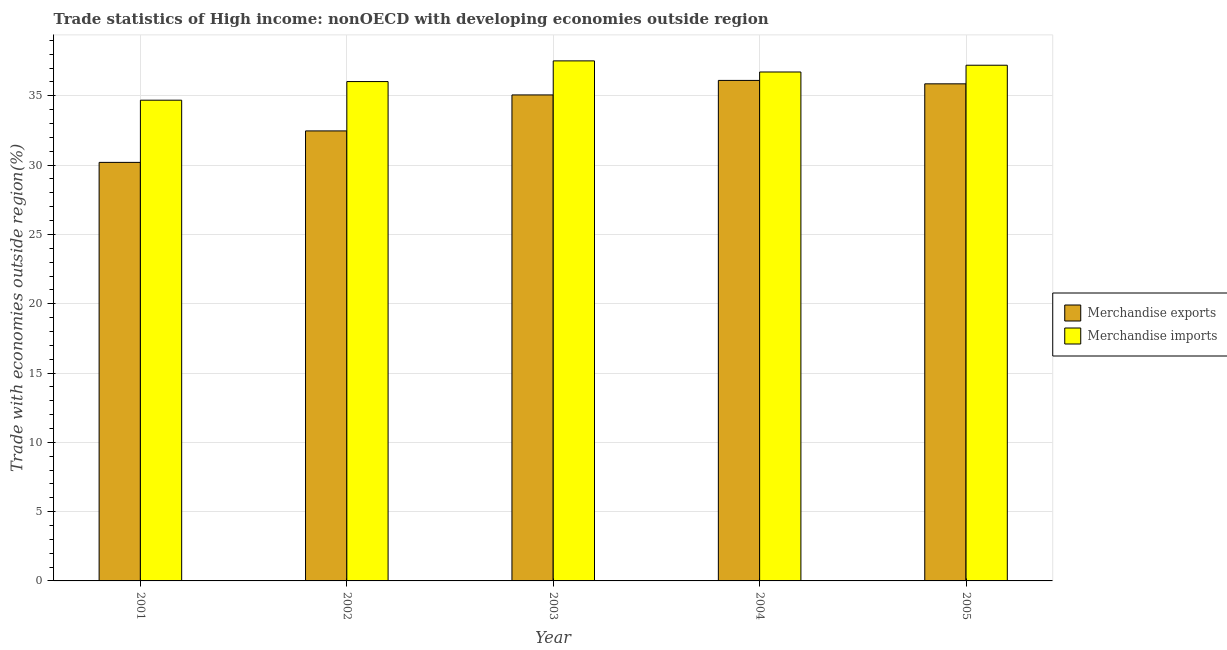How many different coloured bars are there?
Provide a succinct answer. 2. How many groups of bars are there?
Provide a succinct answer. 5. How many bars are there on the 3rd tick from the left?
Your answer should be very brief. 2. How many bars are there on the 1st tick from the right?
Make the answer very short. 2. What is the label of the 2nd group of bars from the left?
Make the answer very short. 2002. What is the merchandise exports in 2003?
Your answer should be compact. 35.07. Across all years, what is the maximum merchandise exports?
Ensure brevity in your answer.  36.11. Across all years, what is the minimum merchandise exports?
Offer a very short reply. 30.2. In which year was the merchandise exports maximum?
Keep it short and to the point. 2004. What is the total merchandise imports in the graph?
Make the answer very short. 182.17. What is the difference between the merchandise imports in 2002 and that in 2003?
Your answer should be compact. -1.49. What is the difference between the merchandise imports in 2001 and the merchandise exports in 2002?
Ensure brevity in your answer.  -1.34. What is the average merchandise imports per year?
Provide a succinct answer. 36.43. In the year 2002, what is the difference between the merchandise imports and merchandise exports?
Give a very brief answer. 0. In how many years, is the merchandise exports greater than 30 %?
Ensure brevity in your answer.  5. What is the ratio of the merchandise imports in 2001 to that in 2004?
Keep it short and to the point. 0.94. Is the difference between the merchandise exports in 2004 and 2005 greater than the difference between the merchandise imports in 2004 and 2005?
Give a very brief answer. No. What is the difference between the highest and the second highest merchandise exports?
Make the answer very short. 0.25. What is the difference between the highest and the lowest merchandise imports?
Provide a short and direct response. 2.84. In how many years, is the merchandise exports greater than the average merchandise exports taken over all years?
Your response must be concise. 3. What does the 1st bar from the left in 2005 represents?
Your answer should be compact. Merchandise exports. How many years are there in the graph?
Give a very brief answer. 5. What is the difference between two consecutive major ticks on the Y-axis?
Make the answer very short. 5. Are the values on the major ticks of Y-axis written in scientific E-notation?
Offer a very short reply. No. Does the graph contain grids?
Offer a terse response. Yes. What is the title of the graph?
Provide a succinct answer. Trade statistics of High income: nonOECD with developing economies outside region. Does "Domestic liabilities" appear as one of the legend labels in the graph?
Provide a succinct answer. No. What is the label or title of the X-axis?
Ensure brevity in your answer.  Year. What is the label or title of the Y-axis?
Your response must be concise. Trade with economies outside region(%). What is the Trade with economies outside region(%) in Merchandise exports in 2001?
Your answer should be very brief. 30.2. What is the Trade with economies outside region(%) of Merchandise imports in 2001?
Provide a succinct answer. 34.69. What is the Trade with economies outside region(%) in Merchandise exports in 2002?
Ensure brevity in your answer.  32.47. What is the Trade with economies outside region(%) in Merchandise imports in 2002?
Your answer should be compact. 36.03. What is the Trade with economies outside region(%) in Merchandise exports in 2003?
Ensure brevity in your answer.  35.07. What is the Trade with economies outside region(%) of Merchandise imports in 2003?
Give a very brief answer. 37.52. What is the Trade with economies outside region(%) in Merchandise exports in 2004?
Offer a very short reply. 36.11. What is the Trade with economies outside region(%) of Merchandise imports in 2004?
Give a very brief answer. 36.72. What is the Trade with economies outside region(%) in Merchandise exports in 2005?
Offer a very short reply. 35.87. What is the Trade with economies outside region(%) of Merchandise imports in 2005?
Ensure brevity in your answer.  37.21. Across all years, what is the maximum Trade with economies outside region(%) of Merchandise exports?
Make the answer very short. 36.11. Across all years, what is the maximum Trade with economies outside region(%) in Merchandise imports?
Give a very brief answer. 37.52. Across all years, what is the minimum Trade with economies outside region(%) in Merchandise exports?
Your answer should be very brief. 30.2. Across all years, what is the minimum Trade with economies outside region(%) in Merchandise imports?
Your response must be concise. 34.69. What is the total Trade with economies outside region(%) in Merchandise exports in the graph?
Offer a very short reply. 169.71. What is the total Trade with economies outside region(%) in Merchandise imports in the graph?
Offer a very short reply. 182.16. What is the difference between the Trade with economies outside region(%) in Merchandise exports in 2001 and that in 2002?
Your answer should be very brief. -2.27. What is the difference between the Trade with economies outside region(%) of Merchandise imports in 2001 and that in 2002?
Your answer should be compact. -1.34. What is the difference between the Trade with economies outside region(%) of Merchandise exports in 2001 and that in 2003?
Provide a succinct answer. -4.87. What is the difference between the Trade with economies outside region(%) in Merchandise imports in 2001 and that in 2003?
Your answer should be compact. -2.84. What is the difference between the Trade with economies outside region(%) in Merchandise exports in 2001 and that in 2004?
Ensure brevity in your answer.  -5.91. What is the difference between the Trade with economies outside region(%) in Merchandise imports in 2001 and that in 2004?
Provide a succinct answer. -2.03. What is the difference between the Trade with economies outside region(%) in Merchandise exports in 2001 and that in 2005?
Your answer should be very brief. -5.67. What is the difference between the Trade with economies outside region(%) of Merchandise imports in 2001 and that in 2005?
Provide a short and direct response. -2.52. What is the difference between the Trade with economies outside region(%) in Merchandise exports in 2002 and that in 2003?
Offer a very short reply. -2.6. What is the difference between the Trade with economies outside region(%) of Merchandise imports in 2002 and that in 2003?
Give a very brief answer. -1.49. What is the difference between the Trade with economies outside region(%) of Merchandise exports in 2002 and that in 2004?
Offer a terse response. -3.64. What is the difference between the Trade with economies outside region(%) of Merchandise imports in 2002 and that in 2004?
Ensure brevity in your answer.  -0.69. What is the difference between the Trade with economies outside region(%) in Merchandise exports in 2002 and that in 2005?
Offer a very short reply. -3.4. What is the difference between the Trade with economies outside region(%) of Merchandise imports in 2002 and that in 2005?
Keep it short and to the point. -1.18. What is the difference between the Trade with economies outside region(%) of Merchandise exports in 2003 and that in 2004?
Make the answer very short. -1.05. What is the difference between the Trade with economies outside region(%) of Merchandise imports in 2003 and that in 2004?
Your response must be concise. 0.8. What is the difference between the Trade with economies outside region(%) in Merchandise exports in 2003 and that in 2005?
Your answer should be compact. -0.8. What is the difference between the Trade with economies outside region(%) in Merchandise imports in 2003 and that in 2005?
Your answer should be compact. 0.31. What is the difference between the Trade with economies outside region(%) in Merchandise exports in 2004 and that in 2005?
Provide a short and direct response. 0.25. What is the difference between the Trade with economies outside region(%) in Merchandise imports in 2004 and that in 2005?
Give a very brief answer. -0.49. What is the difference between the Trade with economies outside region(%) of Merchandise exports in 2001 and the Trade with economies outside region(%) of Merchandise imports in 2002?
Make the answer very short. -5.83. What is the difference between the Trade with economies outside region(%) of Merchandise exports in 2001 and the Trade with economies outside region(%) of Merchandise imports in 2003?
Provide a succinct answer. -7.32. What is the difference between the Trade with economies outside region(%) in Merchandise exports in 2001 and the Trade with economies outside region(%) in Merchandise imports in 2004?
Provide a short and direct response. -6.52. What is the difference between the Trade with economies outside region(%) in Merchandise exports in 2001 and the Trade with economies outside region(%) in Merchandise imports in 2005?
Make the answer very short. -7.01. What is the difference between the Trade with economies outside region(%) in Merchandise exports in 2002 and the Trade with economies outside region(%) in Merchandise imports in 2003?
Your answer should be very brief. -5.05. What is the difference between the Trade with economies outside region(%) in Merchandise exports in 2002 and the Trade with economies outside region(%) in Merchandise imports in 2004?
Offer a terse response. -4.25. What is the difference between the Trade with economies outside region(%) in Merchandise exports in 2002 and the Trade with economies outside region(%) in Merchandise imports in 2005?
Make the answer very short. -4.74. What is the difference between the Trade with economies outside region(%) in Merchandise exports in 2003 and the Trade with economies outside region(%) in Merchandise imports in 2004?
Your answer should be very brief. -1.65. What is the difference between the Trade with economies outside region(%) of Merchandise exports in 2003 and the Trade with economies outside region(%) of Merchandise imports in 2005?
Provide a short and direct response. -2.14. What is the difference between the Trade with economies outside region(%) of Merchandise exports in 2004 and the Trade with economies outside region(%) of Merchandise imports in 2005?
Provide a succinct answer. -1.1. What is the average Trade with economies outside region(%) of Merchandise exports per year?
Keep it short and to the point. 33.94. What is the average Trade with economies outside region(%) in Merchandise imports per year?
Keep it short and to the point. 36.43. In the year 2001, what is the difference between the Trade with economies outside region(%) of Merchandise exports and Trade with economies outside region(%) of Merchandise imports?
Give a very brief answer. -4.49. In the year 2002, what is the difference between the Trade with economies outside region(%) of Merchandise exports and Trade with economies outside region(%) of Merchandise imports?
Offer a terse response. -3.56. In the year 2003, what is the difference between the Trade with economies outside region(%) of Merchandise exports and Trade with economies outside region(%) of Merchandise imports?
Keep it short and to the point. -2.46. In the year 2004, what is the difference between the Trade with economies outside region(%) of Merchandise exports and Trade with economies outside region(%) of Merchandise imports?
Provide a succinct answer. -0.61. In the year 2005, what is the difference between the Trade with economies outside region(%) in Merchandise exports and Trade with economies outside region(%) in Merchandise imports?
Offer a very short reply. -1.34. What is the ratio of the Trade with economies outside region(%) in Merchandise exports in 2001 to that in 2002?
Your response must be concise. 0.93. What is the ratio of the Trade with economies outside region(%) in Merchandise imports in 2001 to that in 2002?
Offer a terse response. 0.96. What is the ratio of the Trade with economies outside region(%) of Merchandise exports in 2001 to that in 2003?
Your response must be concise. 0.86. What is the ratio of the Trade with economies outside region(%) in Merchandise imports in 2001 to that in 2003?
Make the answer very short. 0.92. What is the ratio of the Trade with economies outside region(%) in Merchandise exports in 2001 to that in 2004?
Ensure brevity in your answer.  0.84. What is the ratio of the Trade with economies outside region(%) in Merchandise imports in 2001 to that in 2004?
Your response must be concise. 0.94. What is the ratio of the Trade with economies outside region(%) of Merchandise exports in 2001 to that in 2005?
Your answer should be compact. 0.84. What is the ratio of the Trade with economies outside region(%) in Merchandise imports in 2001 to that in 2005?
Provide a succinct answer. 0.93. What is the ratio of the Trade with economies outside region(%) in Merchandise exports in 2002 to that in 2003?
Your response must be concise. 0.93. What is the ratio of the Trade with economies outside region(%) in Merchandise imports in 2002 to that in 2003?
Provide a succinct answer. 0.96. What is the ratio of the Trade with economies outside region(%) in Merchandise exports in 2002 to that in 2004?
Ensure brevity in your answer.  0.9. What is the ratio of the Trade with economies outside region(%) in Merchandise imports in 2002 to that in 2004?
Offer a terse response. 0.98. What is the ratio of the Trade with economies outside region(%) in Merchandise exports in 2002 to that in 2005?
Offer a terse response. 0.91. What is the ratio of the Trade with economies outside region(%) in Merchandise imports in 2002 to that in 2005?
Your answer should be very brief. 0.97. What is the ratio of the Trade with economies outside region(%) of Merchandise exports in 2003 to that in 2004?
Your answer should be very brief. 0.97. What is the ratio of the Trade with economies outside region(%) of Merchandise imports in 2003 to that in 2004?
Ensure brevity in your answer.  1.02. What is the ratio of the Trade with economies outside region(%) of Merchandise exports in 2003 to that in 2005?
Provide a succinct answer. 0.98. What is the ratio of the Trade with economies outside region(%) of Merchandise imports in 2003 to that in 2005?
Ensure brevity in your answer.  1.01. What is the ratio of the Trade with economies outside region(%) in Merchandise imports in 2004 to that in 2005?
Your answer should be compact. 0.99. What is the difference between the highest and the second highest Trade with economies outside region(%) in Merchandise exports?
Your answer should be very brief. 0.25. What is the difference between the highest and the second highest Trade with economies outside region(%) in Merchandise imports?
Keep it short and to the point. 0.31. What is the difference between the highest and the lowest Trade with economies outside region(%) in Merchandise exports?
Offer a very short reply. 5.91. What is the difference between the highest and the lowest Trade with economies outside region(%) of Merchandise imports?
Offer a very short reply. 2.84. 